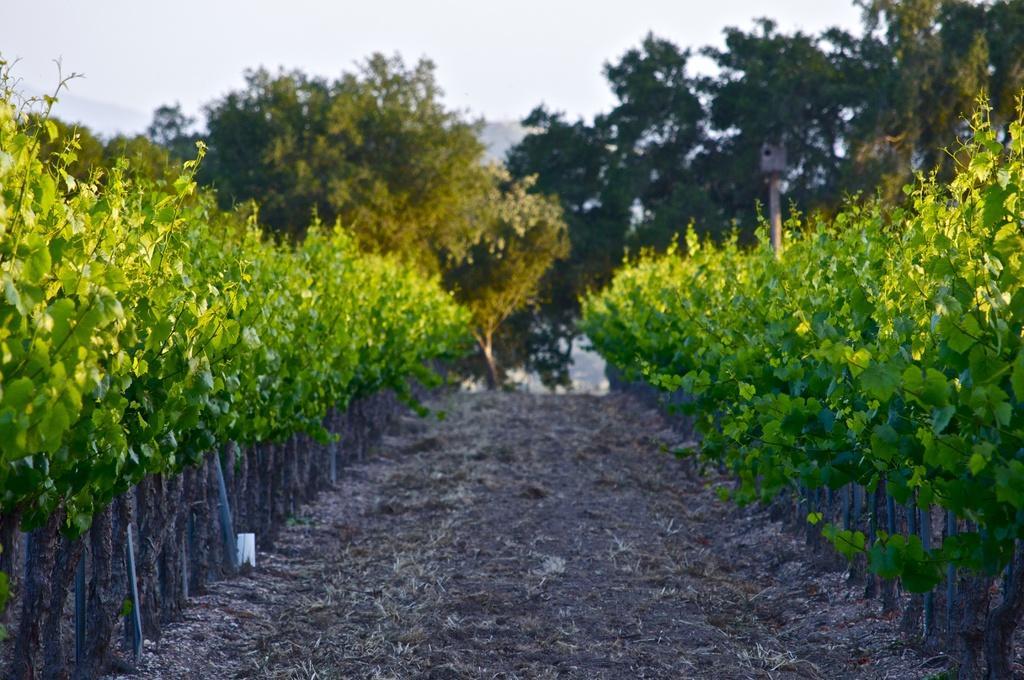In one or two sentences, can you explain what this image depicts? In this image we can see walkway, there are some plants on left and right side of the image and in the background of the image there are some trees and clear sky. 